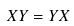<formula> <loc_0><loc_0><loc_500><loc_500>X Y = Y X</formula> 